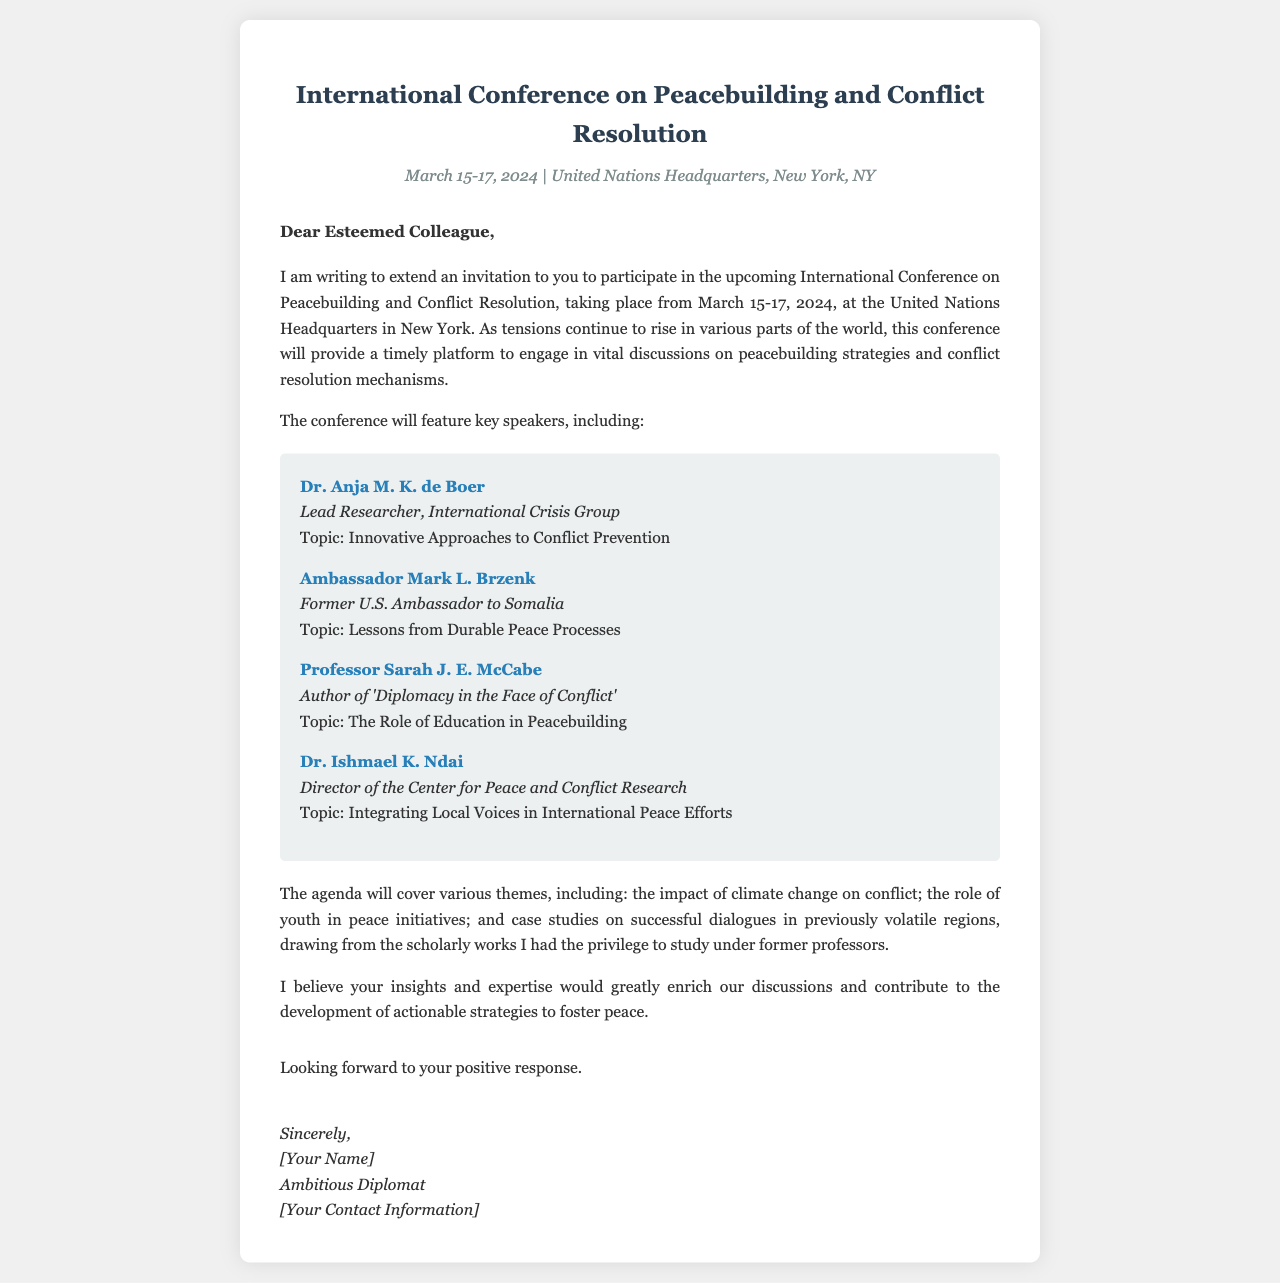What are the dates of the conference? The dates of the conference are explicitly mentioned in the document as March 15-17, 2024.
Answer: March 15-17, 2024 Who is the lead researcher at the International Crisis Group? The document provides the name of the lead researcher as Dr. Anja M. K. de Boer.
Answer: Dr. Anja M. K. de Boer What topic will Professor Sarah J. E. McCabe discuss? The topic assigned to Professor Sarah J. E. McCabe in the document is "The Role of Education in Peacebuilding."
Answer: The Role of Education in Peacebuilding Where is the conference being held? The location of the conference is clearly stated as the United Nations Headquarters, New York, NY.
Answer: United Nations Headquarters, New York, NY What is one theme that will be covered in the agenda? The document mentions various themes, one of which is "the impact of climate change on conflict."
Answer: the impact of climate change on conflict What is the purpose of the conference? The purpose of the conference is articulated as providing a platform for discussions on peacebuilding strategies and conflict resolution mechanisms.
Answer: discussions on peacebuilding strategies and conflict resolution mechanisms Who signed the letter? The signature section of the document indicates it was signed by "Ambitious Diplomat."
Answer: Ambitious Diplomat What major topic does Ambassador Mark L. Brzenk cover? The document states that Ambassador Mark L. Brzenk will discuss "Lessons from Durable Peace Processes."
Answer: Lessons from Durable Peace Processes 